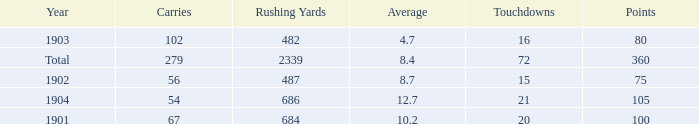What is the total number of rushing yards associated with averages over 8.4 and fewer than 54 carries? 0.0. 